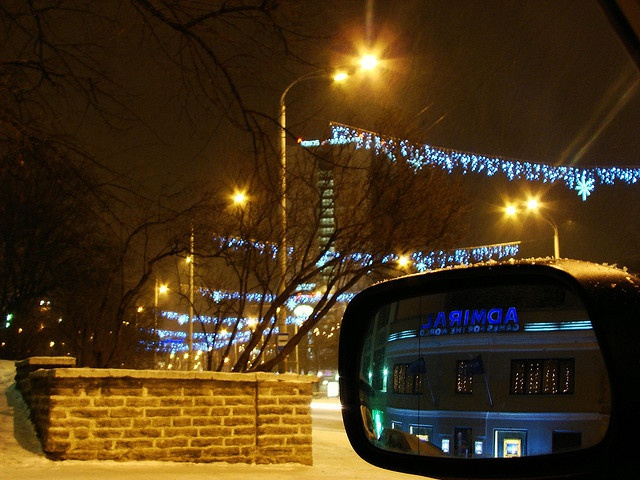Describe the objects in this image and their specific colors. I can see a car in black, navy, blue, and maroon tones in this image. 